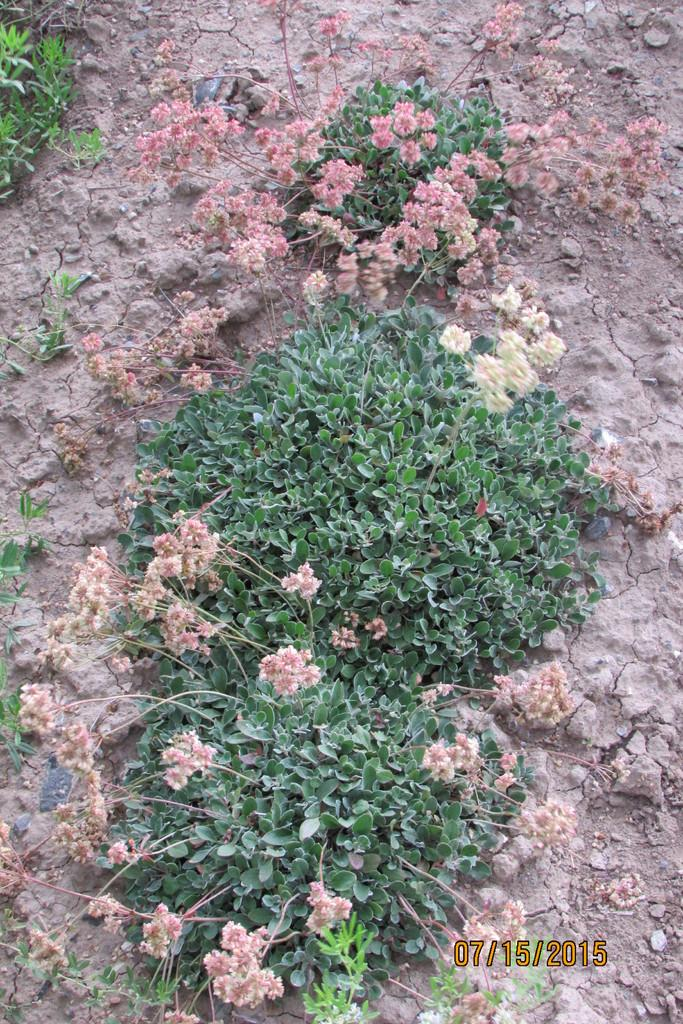What type of plants are visible in the image? There are plants with flowers on the ground in the image. Can you describe any additional features in the image? There is a watermark in the right bottom corner of the image. What type of window can be seen in the image? There is no window present in the image; it only features plants with flowers and a watermark. 